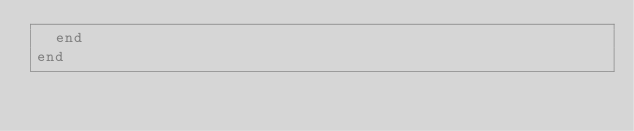<code> <loc_0><loc_0><loc_500><loc_500><_Ruby_>  end
end
</code> 